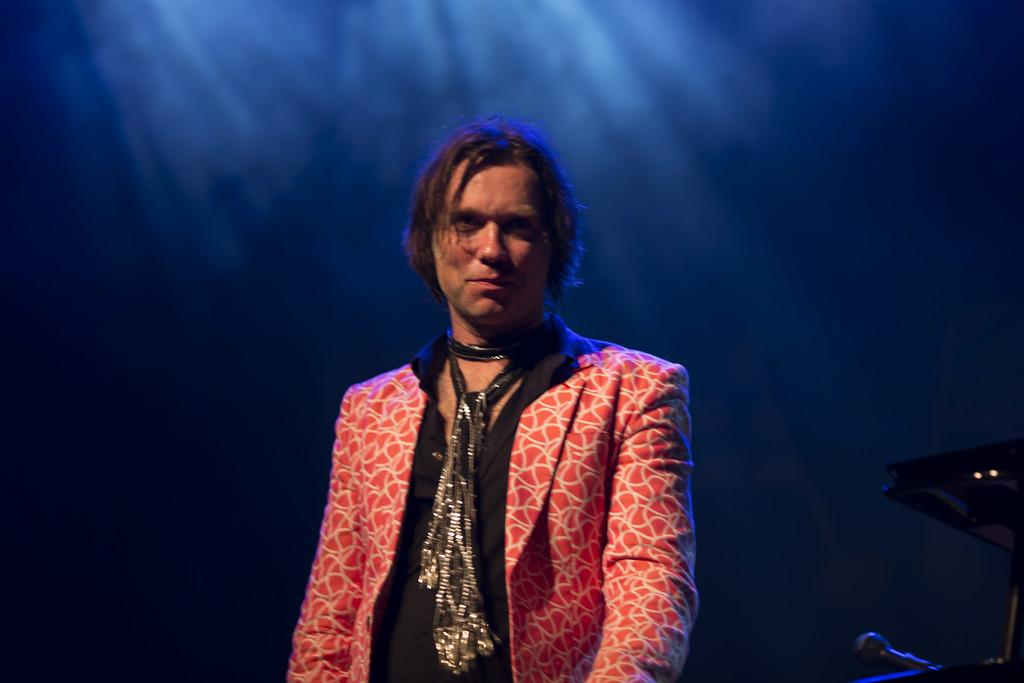What is the main subject of the image? There is a person standing in the center of the image. What can be seen on the right side of the image? There are objects on the right side of the image. Can you describe the background of the image? The background of the image appears to be black. Is there any source of light in the image? Yes, there is a light source in the background of the image. What type of bubble is being used in the operation depicted in the image? There is no operation or bubble present in the image. 